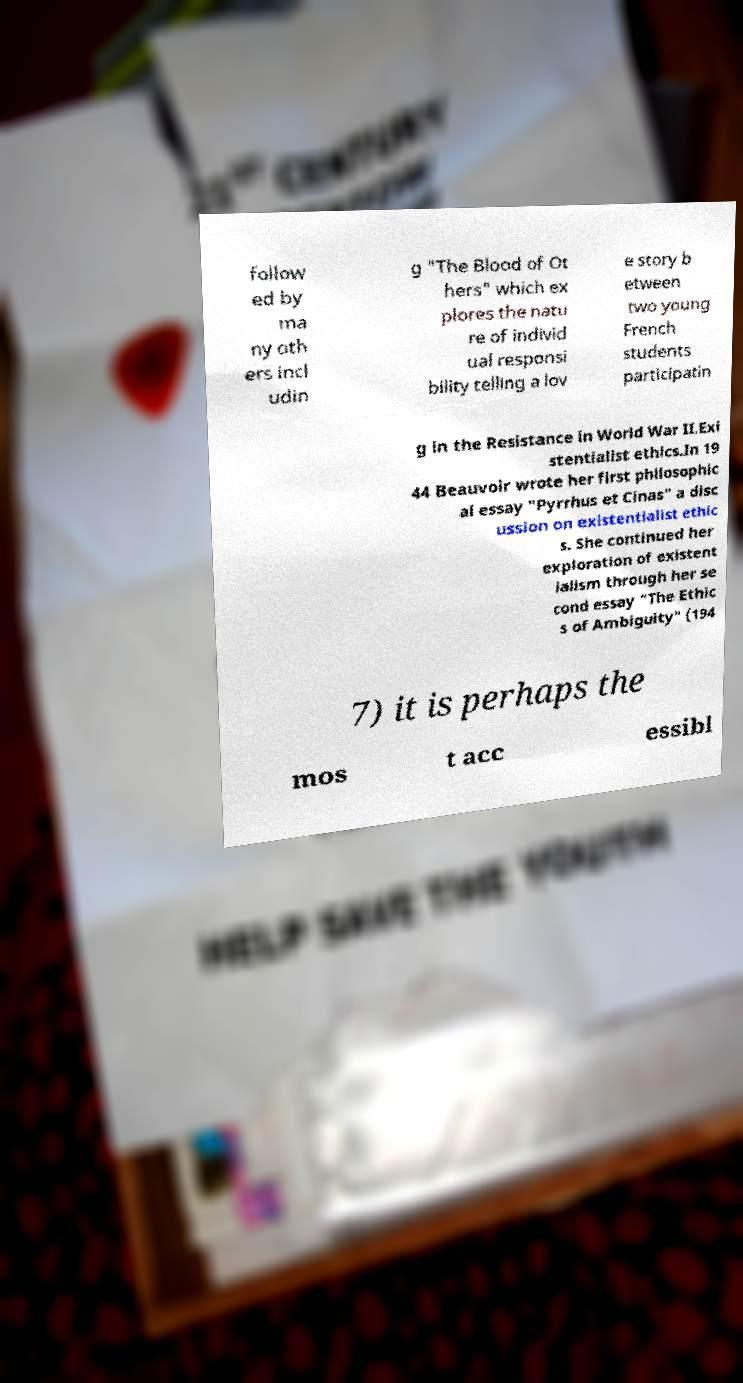For documentation purposes, I need the text within this image transcribed. Could you provide that? follow ed by ma ny oth ers incl udin g "The Blood of Ot hers" which ex plores the natu re of individ ual responsi bility telling a lov e story b etween two young French students participatin g in the Resistance in World War II.Exi stentialist ethics.In 19 44 Beauvoir wrote her first philosophic al essay "Pyrrhus et Cinas" a disc ussion on existentialist ethic s. She continued her exploration of existent ialism through her se cond essay "The Ethic s of Ambiguity" (194 7) it is perhaps the mos t acc essibl 